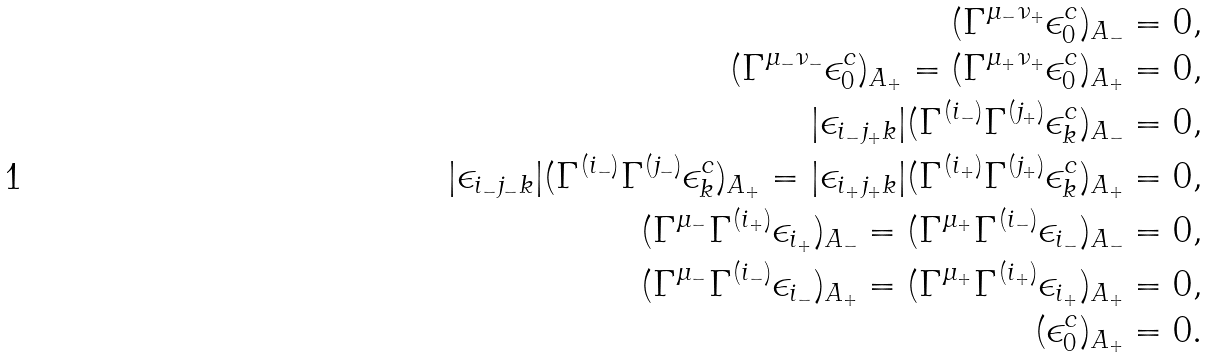<formula> <loc_0><loc_0><loc_500><loc_500>( \Gamma ^ { \mu _ { - } \nu _ { + } } \epsilon _ { 0 } ^ { c } ) _ { A _ { - } } = 0 , \\ ( \Gamma ^ { \mu _ { - } \nu _ { - } } \epsilon _ { 0 } ^ { c } ) _ { A _ { + } } = ( \Gamma ^ { \mu _ { + } \nu _ { + } } \epsilon _ { 0 } ^ { c } ) _ { A _ { + } } = 0 , \\ | \epsilon _ { i _ { - } j _ { + } k } | ( \Gamma ^ { ( i _ { - } ) } \Gamma ^ { ( j _ { + } ) } \epsilon _ { k } ^ { c } ) _ { A _ { - } } = 0 , \\ | \epsilon _ { i _ { - } j _ { - } k } | ( \Gamma ^ { ( i _ { - } ) } \Gamma ^ { ( j _ { - } ) } \epsilon _ { k } ^ { c } ) _ { A _ { + } } = | \epsilon _ { i _ { + } j _ { + } k } | ( \Gamma ^ { ( i _ { + } ) } \Gamma ^ { ( j _ { + } ) } \epsilon _ { k } ^ { c } ) _ { A _ { + } } = 0 , \\ ( \Gamma ^ { \mu _ { - } } \Gamma ^ { ( i _ { + } ) } \epsilon _ { i _ { + } } ) _ { A _ { - } } = ( \Gamma ^ { \mu _ { + } } \Gamma ^ { ( i _ { - } ) } \epsilon _ { i _ { - } } ) _ { A _ { - } } = 0 , \\ ( \Gamma ^ { \mu _ { - } } \Gamma ^ { ( i _ { - } ) } \epsilon _ { i _ { - } } ) _ { A _ { + } } = ( \Gamma ^ { \mu _ { + } } \Gamma ^ { ( i _ { + } ) } \epsilon _ { i _ { + } } ) _ { A _ { + } } = 0 , \\ ( \epsilon _ { 0 } ^ { c } ) _ { A _ { + } } = 0 .</formula> 